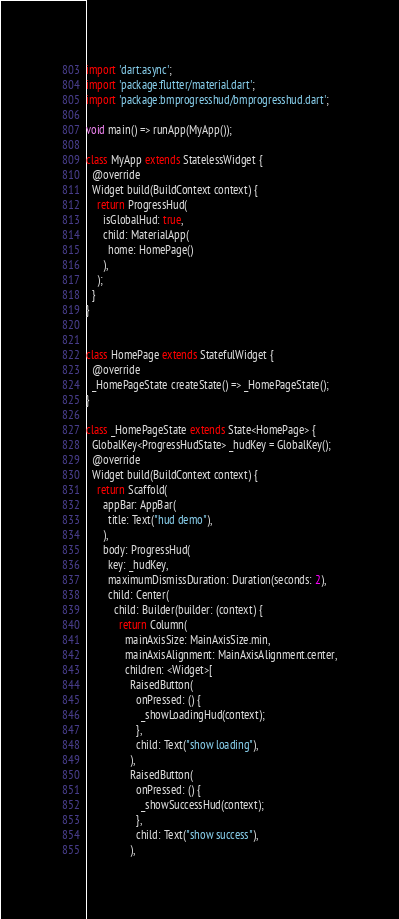<code> <loc_0><loc_0><loc_500><loc_500><_Dart_>import 'dart:async';
import 'package:flutter/material.dart';
import 'package:bmprogresshud/bmprogresshud.dart';

void main() => runApp(MyApp());

class MyApp extends StatelessWidget {
  @override
  Widget build(BuildContext context) {
    return ProgressHud(
      isGlobalHud: true,
      child: MaterialApp(
        home: HomePage()
      ),
    );
  }
}


class HomePage extends StatefulWidget {
  @override
  _HomePageState createState() => _HomePageState();
}

class _HomePageState extends State<HomePage> {
  GlobalKey<ProgressHudState> _hudKey = GlobalKey();
  @override
  Widget build(BuildContext context) {
    return Scaffold(
      appBar: AppBar(
        title: Text("hud demo"),
      ),
      body: ProgressHud(
        key: _hudKey,
        maximumDismissDuration: Duration(seconds: 2),
        child: Center(
          child: Builder(builder: (context) {
            return Column(
              mainAxisSize: MainAxisSize.min,
              mainAxisAlignment: MainAxisAlignment.center,
              children: <Widget>[
                RaisedButton(
                  onPressed: () {
                    _showLoadingHud(context);
                  },
                  child: Text("show loading"),
                ),
                RaisedButton(
                  onPressed: () {
                    _showSuccessHud(context);
                  },
                  child: Text("show success"),
                ),</code> 